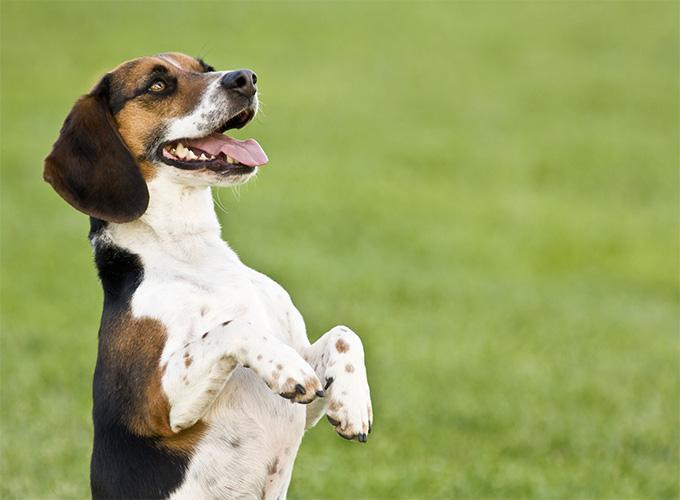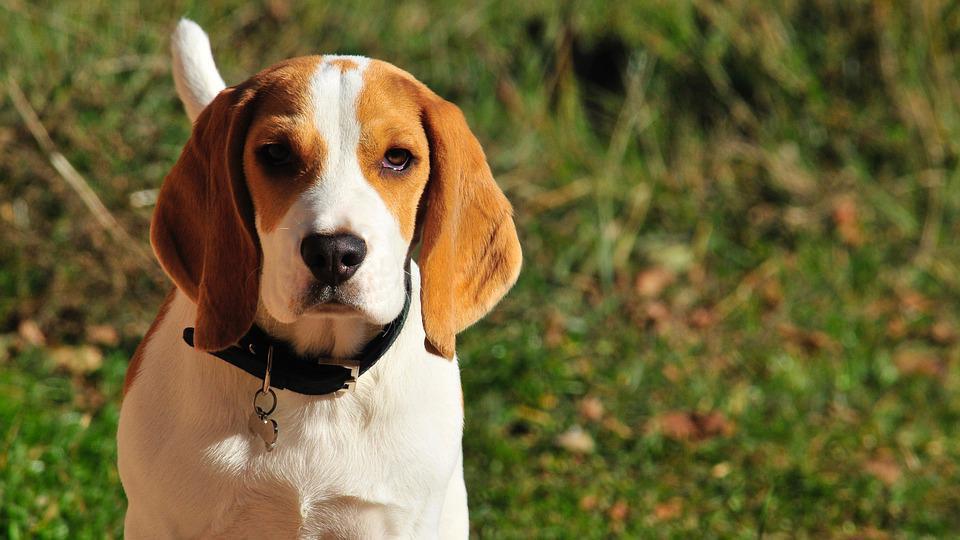The first image is the image on the left, the second image is the image on the right. Analyze the images presented: Is the assertion "At least one dog has its mouth open." valid? Answer yes or no. Yes. 